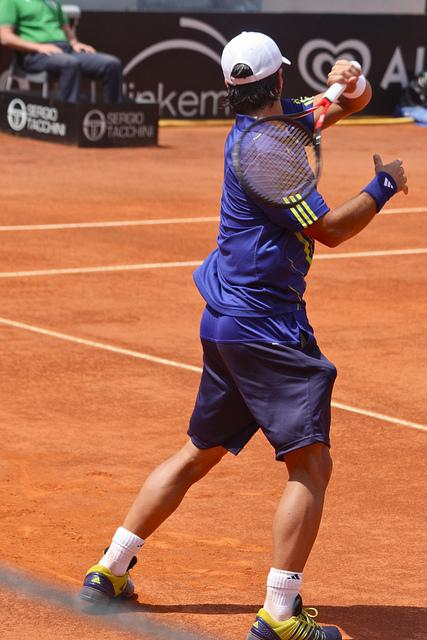What move does this player use?

Choices:
A) forehand
B) backhand
C) serve
D) lob backhand 